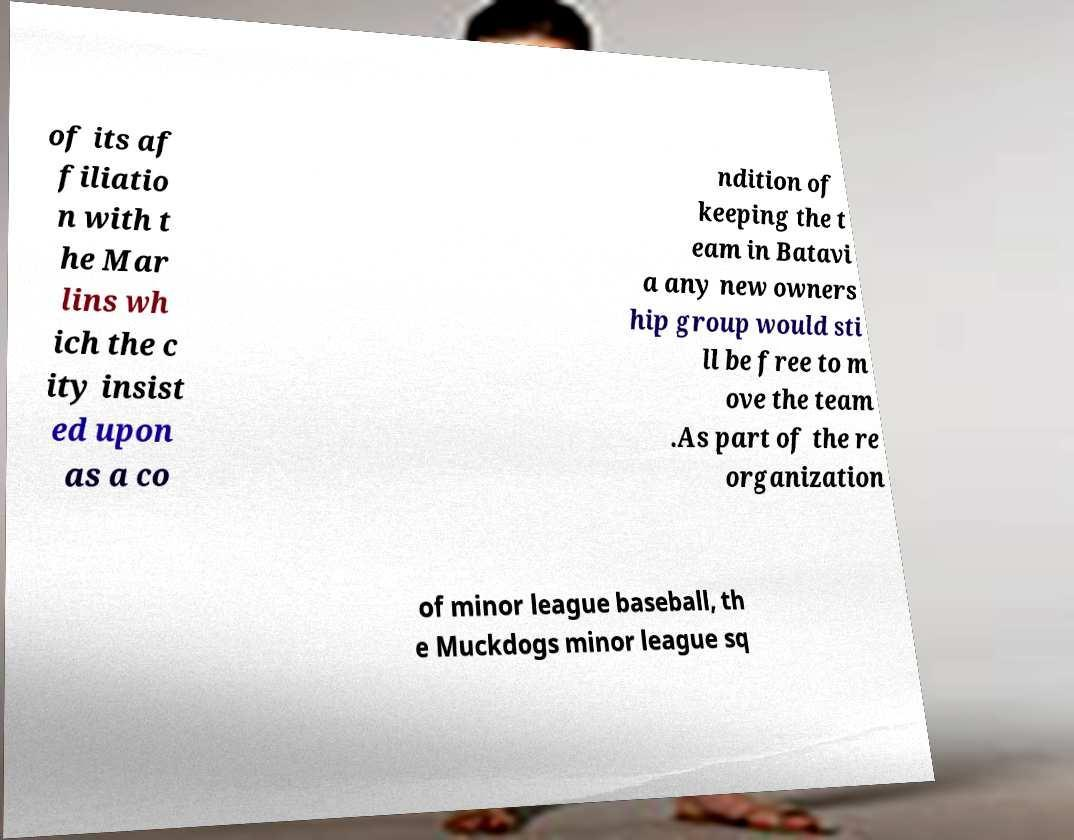Please read and relay the text visible in this image. What does it say? of its af filiatio n with t he Mar lins wh ich the c ity insist ed upon as a co ndition of keeping the t eam in Batavi a any new owners hip group would sti ll be free to m ove the team .As part of the re organization of minor league baseball, th e Muckdogs minor league sq 